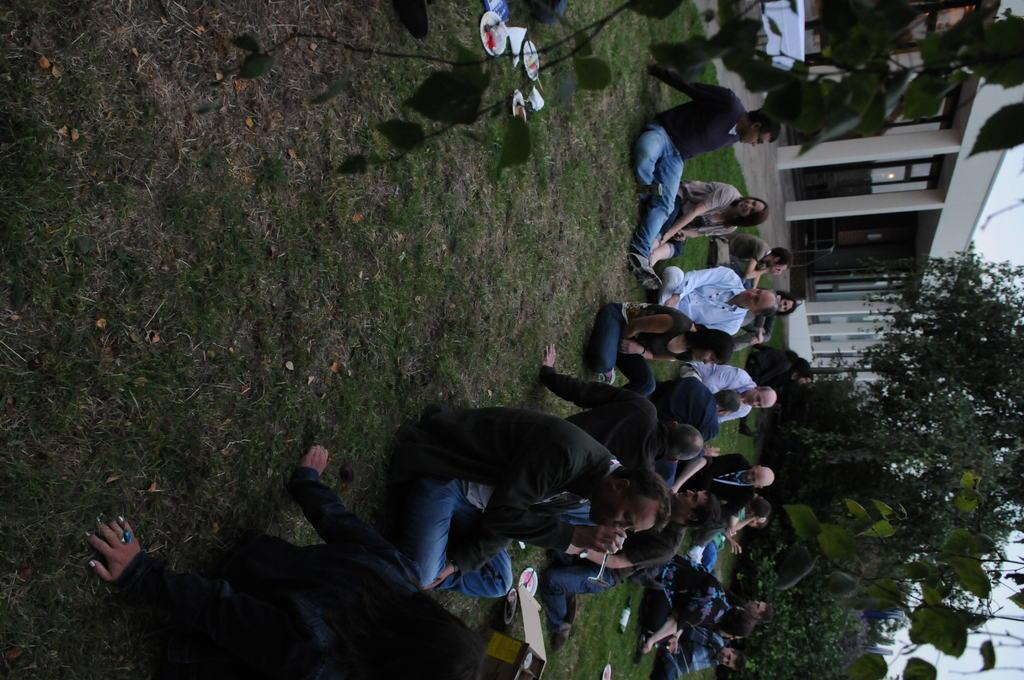What are the people in the image doing? The people in the image are sitting on the ground. What can be seen on the ground near the people? There are plates and papers visible on the ground. What type of vegetation is present in the image? There are plants and trees in the image. What other objects can be seen in the image? There are other objects in the image, but their specific details are not mentioned in the facts. Can you describe the building in the image? The building in the image has pillars and doors. What type of apparatus is used for sound amplification in the image? There is no apparatus for sound amplification present in the image. Can you describe the zebra's stripes in the image? There is no zebra present in the image. 